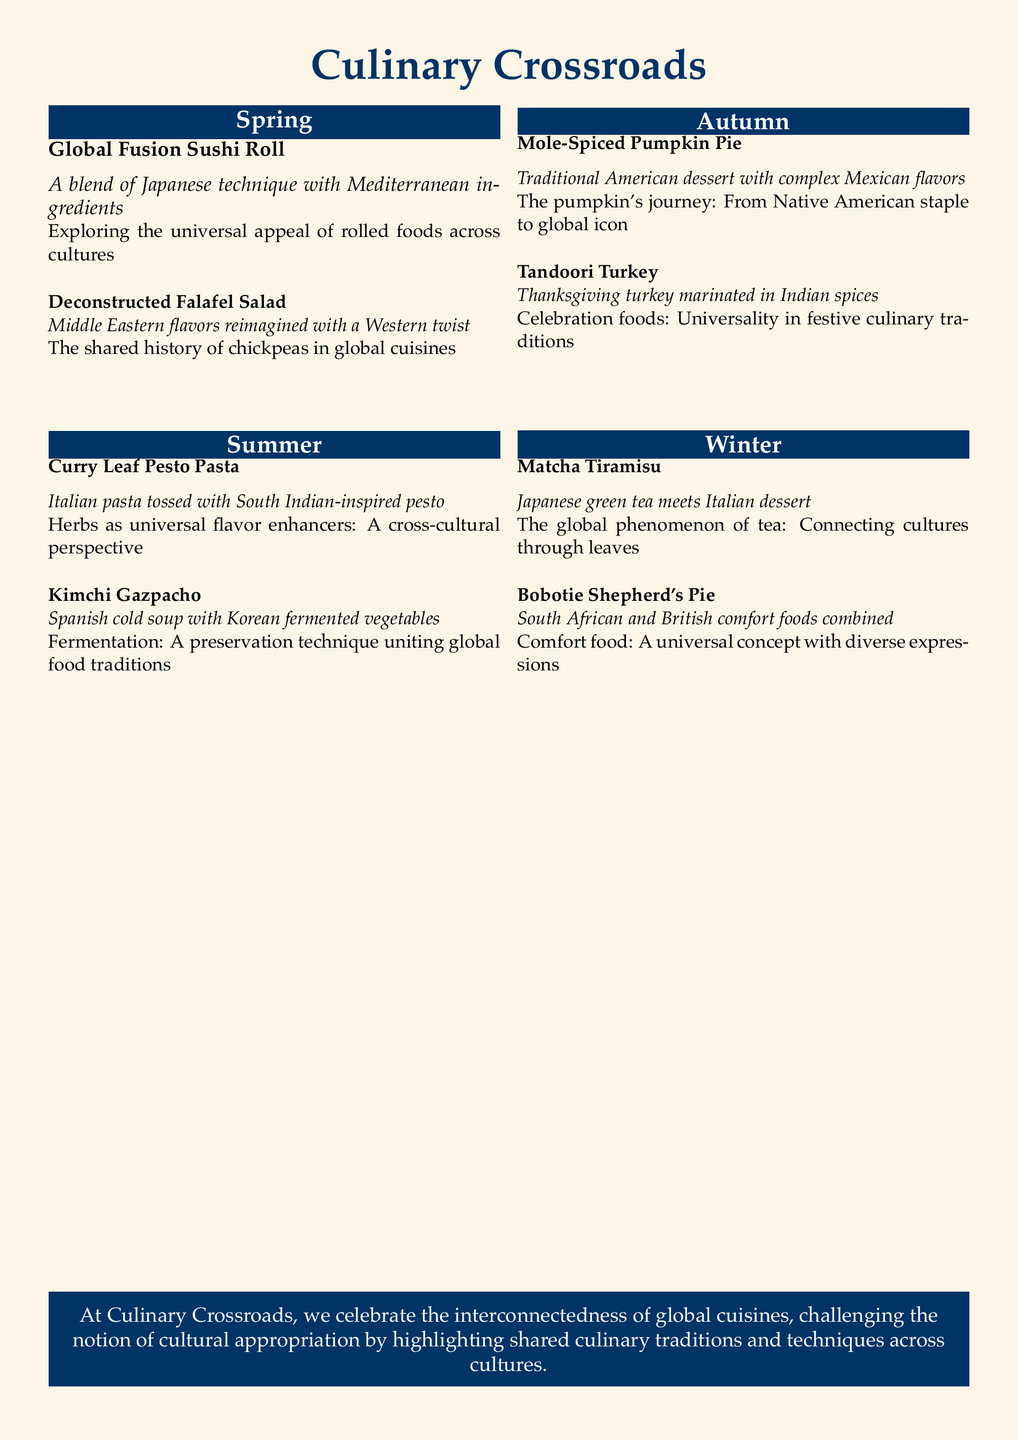What is the name of the restaurant? The name of the restaurant is prominently displayed at the top of the document in a larger font.
Answer: Culinary Crossroads How many seasons are featured in the menu? The menu features sections for each season, which are clearly labeled in the document.
Answer: Four What dish combines Japanese and Italian cuisine? The dish that combines these two cuisines is listed under the Winter section, directly in the text.
Answer: Matcha Tiramisu What ingredient is common in both the Deconstructed Falafel Salad and Curry Leaf Pesto Pasta? This ingredient is noted as widely used in multiple cuisines, relevant to their descriptions.
Answer: Chickpeas In which season is the Mole-Spiced Pumpkin Pie offered? The seasonal section in the document specifies where each dish can be found.
Answer: Autumn What type of flavors does the Tandoori Turkey feature? The flavor profile of the dish is described to highlight its culinary influence.
Answer: Indian spices What culinary concept is associated with the Bobotie Shepherd's Pie? The section discussing comfort foods outlines this universal theme.
Answer: Comfort food What preservation technique is highlighted in the Kimchi Gazpacho dish? The document notes the culinary technique that spans various cuisines in the description of this dish.
Answer: Fermentation 